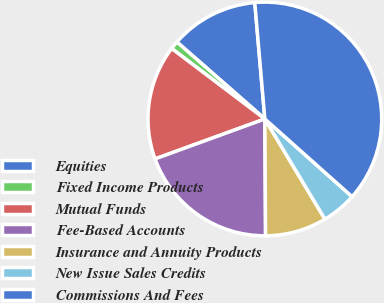Convert chart to OTSL. <chart><loc_0><loc_0><loc_500><loc_500><pie_chart><fcel>Equities<fcel>Fixed Income Products<fcel>Mutual Funds<fcel>Fee-Based Accounts<fcel>Insurance and Annuity Products<fcel>New Issue Sales Credits<fcel>Commissions And Fees<nl><fcel>12.18%<fcel>1.14%<fcel>15.86%<fcel>19.54%<fcel>8.5%<fcel>4.82%<fcel>37.95%<nl></chart> 